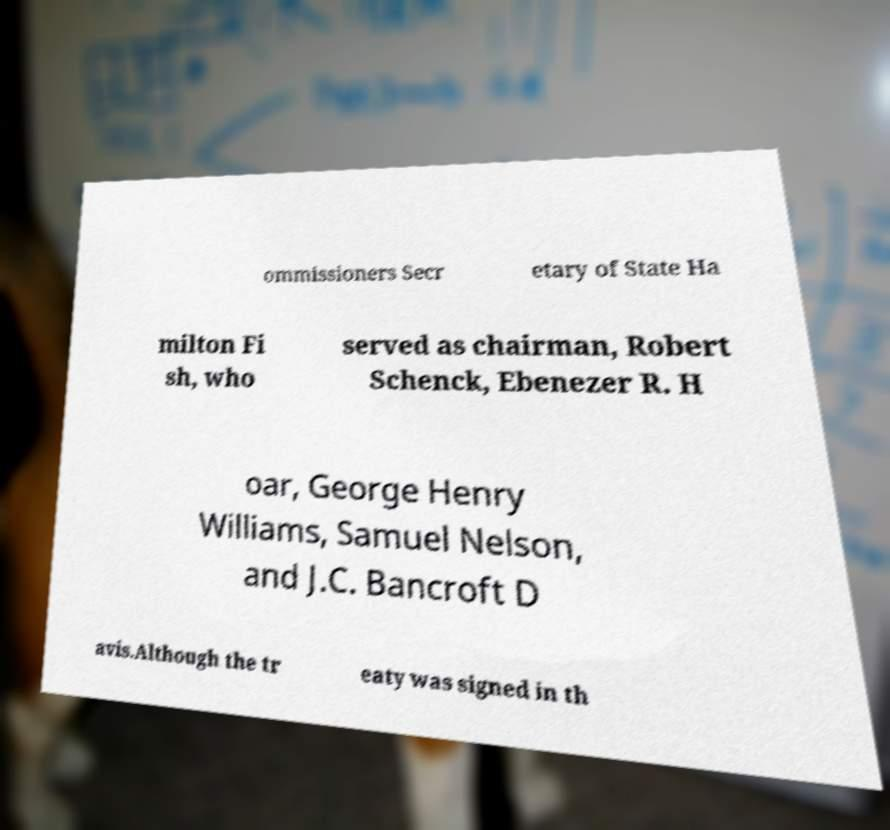There's text embedded in this image that I need extracted. Can you transcribe it verbatim? ommissioners Secr etary of State Ha milton Fi sh, who served as chairman, Robert Schenck, Ebenezer R. H oar, George Henry Williams, Samuel Nelson, and J.C. Bancroft D avis.Although the tr eaty was signed in th 